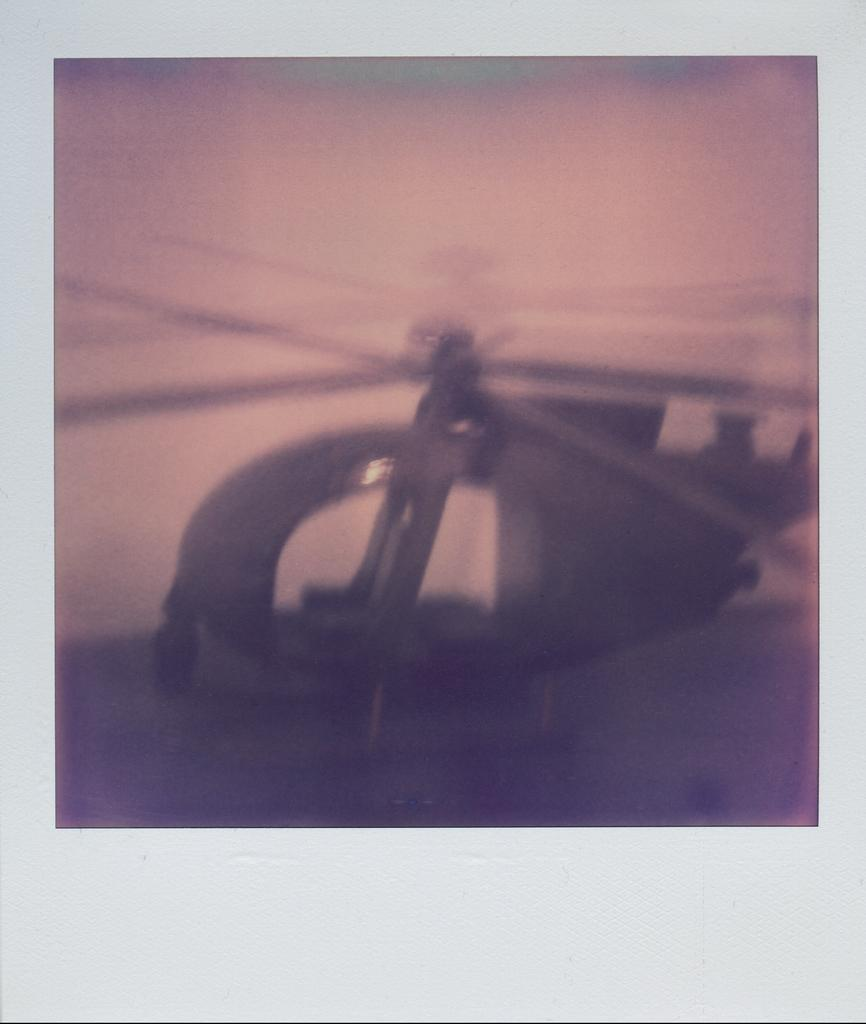What is the main subject of the image? The main subject of the image is a photograph of a helicopter. What type of table is depicted in the image? There is no table present in the image; it features a photograph of a helicopter. What emotion is being expressed by the helicopter in the image? Helicopters do not express emotions, so this question cannot be answered. 